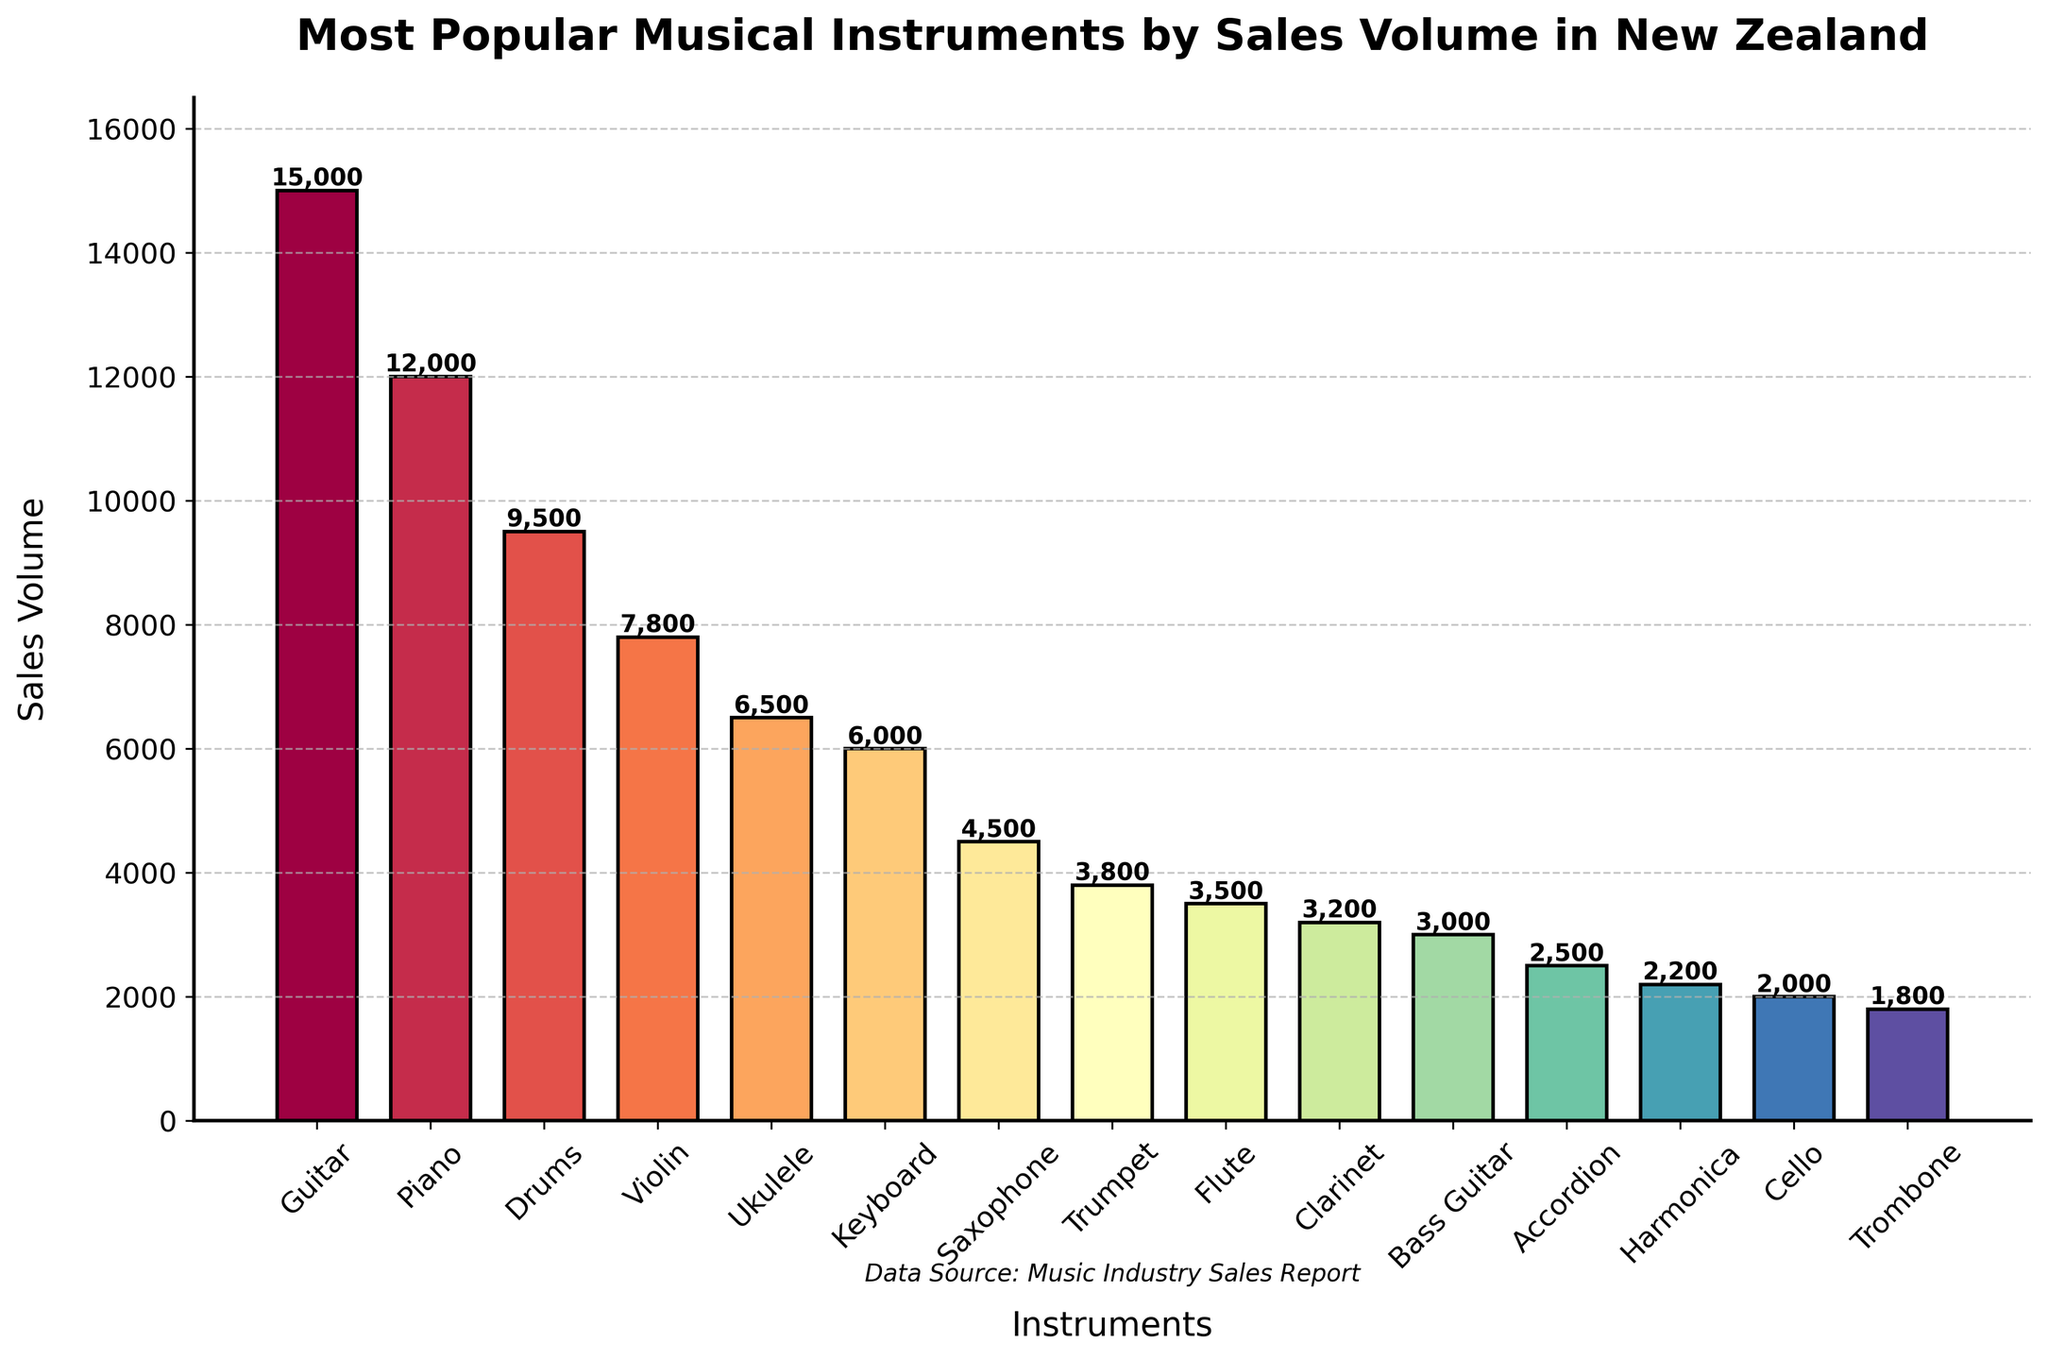Which instrument has the highest sales volume? To find the highest sales volume, look at the bar that stretches the highest in the plot. The Guitar's bar is the tallest, signifying it has the most sales.
Answer: Guitar Which instruments have sales volumes less than 4,000? Sales volumes less than 4,000 correspond to the bars that fall below the horizontal guide mark at 4,000 on the y-axis. These bars are for the Trumpet, Flute, Clarinet, Bass Guitar, Accordion, Harmonica, Cello, and Trombone.
Answer: Trumpet, Flute, Clarinet, Bass Guitar, Accordion, Harmonica, Cello, Trombone What is the combined sales volume of the Piano and Drums? Sum the heights (sales volumes) of the Piano and Drums. Piano has 12,000 and Drums have 9,500. Therefore, the combined sales are 12,000 + 9,500 = 21,500.
Answer: 21,500 Which instrument has a higher sales volume, the Ukulele or the Keyboard? Compare the heights of the bars for the Ukulele and the Keyboard. The Ukulele's bar is taller at 6,500 compared to the Keyboard's 6,000. Thus, the Ukulele has a higher sales volume.
Answer: Ukulele What is the average sales volume of the top three instruments? Look at the highest three bars, which are for the Guitar, Piano, and Drums. Their sales volumes are 15,000, 12,000, and 9,500. Sum these values and divide by 3: (15,000 + 12,000 + 9,500) / 3 = 12,833.33.
Answer: 12,833.33 How much higher are Guitar sales compared to Violin sales? Subtract the sales volume of Violin from that of Guitar. Guitar has 15,000 and Violin 7,800. 15,000 - 7,800 = 7,200.
Answer: 7,200 What is the sales volume range of the instruments presented? The range is found by subtracting the smallest sales volume from the largest. The smallest is Trombone with 1,800, and the largest is Guitar with 15,000. So, 15,000 - 1,800 = 13,200.
Answer: 13,200 Which has more sales, the combination of Harmonica and Cello or the Saxophone alone? First, sum the sales of the Harmonica and Cello: 2,200 + 2,000 = 4,200. Compare this to Saxophone's sales of 4,500. 4,500 is greater than 4,200, so the Saxophone alone has more sales.
Answer: Saxophone Is the difference between the sales volumes of the Drums and Violin greater than the sales volume of the Flute? Calculate the difference: 9,500 (Drums) - 7,800 (Violin) = 1,700. Compare this with Flute's sales of 3,500. Since 1,700 is less than 3,500, the difference is not greater.
Answer: No What's the total sales volume for all instruments combined? Sum all the provided sales volumes: 15,000 + 12,000 + 9,500 + 7,800 + 6,500 + 6,000 + 4,500 + 3,800 + 3,500 + 3,200 + 3,000 + 2,500 + 2,200 + 2,000 + 1,800 = 83,300.
Answer: 83,300 